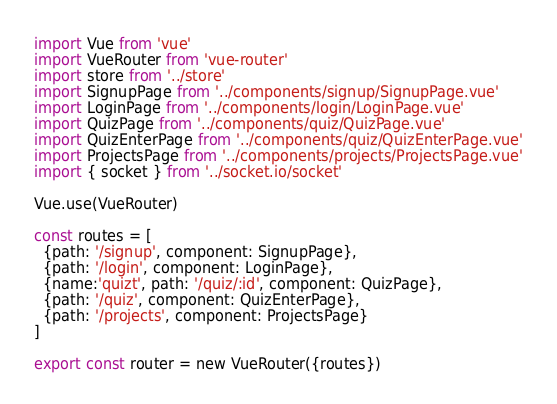<code> <loc_0><loc_0><loc_500><loc_500><_JavaScript_>import Vue from 'vue'
import VueRouter from 'vue-router'
import store from '../store'
import SignupPage from '../components/signup/SignupPage.vue'
import LoginPage from '../components/login/LoginPage.vue'
import QuizPage from '../components/quiz/QuizPage.vue'
import QuizEnterPage from '../components/quiz/QuizEnterPage.vue'
import ProjectsPage from '../components/projects/ProjectsPage.vue'
import { socket } from '../socket.io/socket'

Vue.use(VueRouter)

const routes = [
  {path: '/signup', component: SignupPage},
  {path: '/login', component: LoginPage},
  {name:'quizt', path: '/quiz/:id', component: QuizPage},
  {path: '/quiz', component: QuizEnterPage},
  {path: '/projects', component: ProjectsPage}
]

export const router = new VueRouter({routes})</code> 